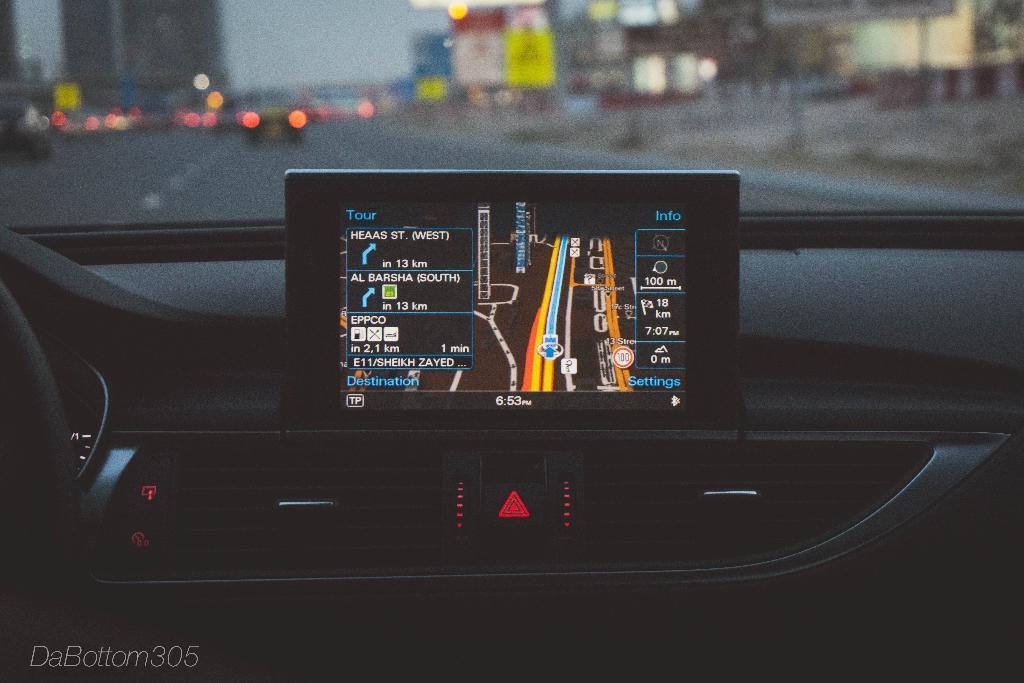What is located at the bottom side of the image? There is a car at the bottom side of the image. What is in the center of the image? There is a screen in the center of the image. What can be seen at the top side of the image? There are cars and trees visible at the top side of the image, as well as posters. How does the car at the top side of the image exchange information with the car at the bottom side of the image? There is no indication in the image that the cars are exchanging information, and they are not shown to be in direct communication. Can you tell me how many times the poster at the top side of the image has been copied? There is no information about the poster being copied in the image, so it cannot be determined. 